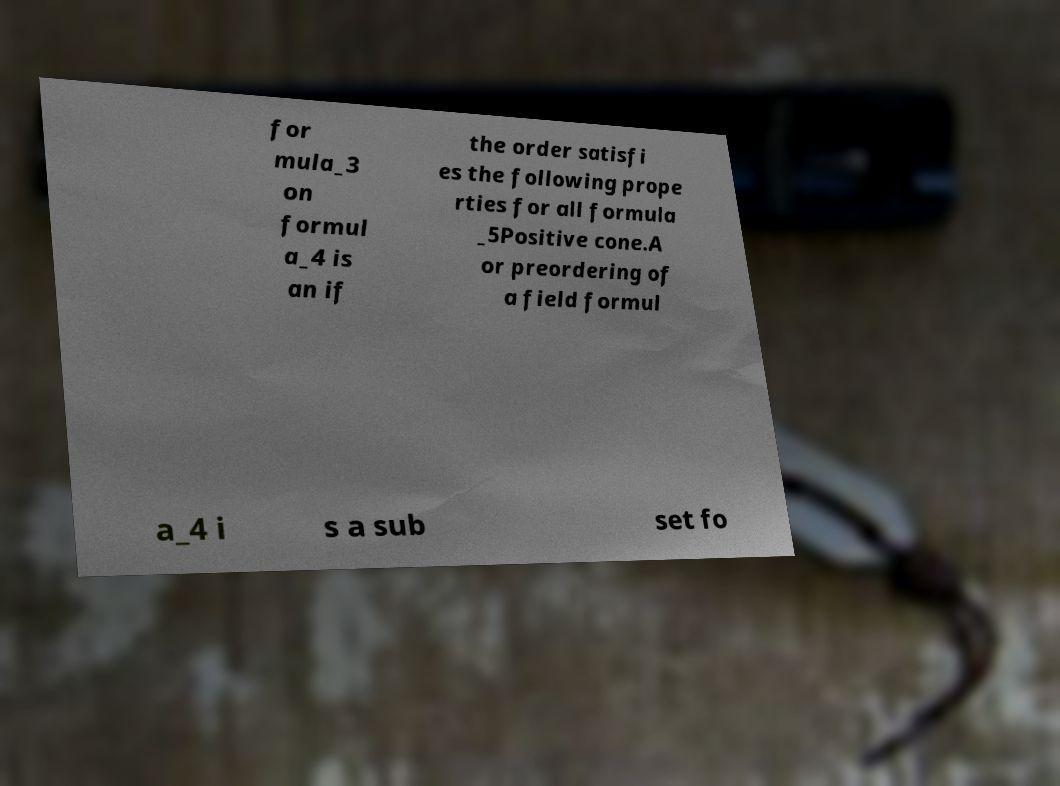Please identify and transcribe the text found in this image. for mula_3 on formul a_4 is an if the order satisfi es the following prope rties for all formula _5Positive cone.A or preordering of a field formul a_4 i s a sub set fo 